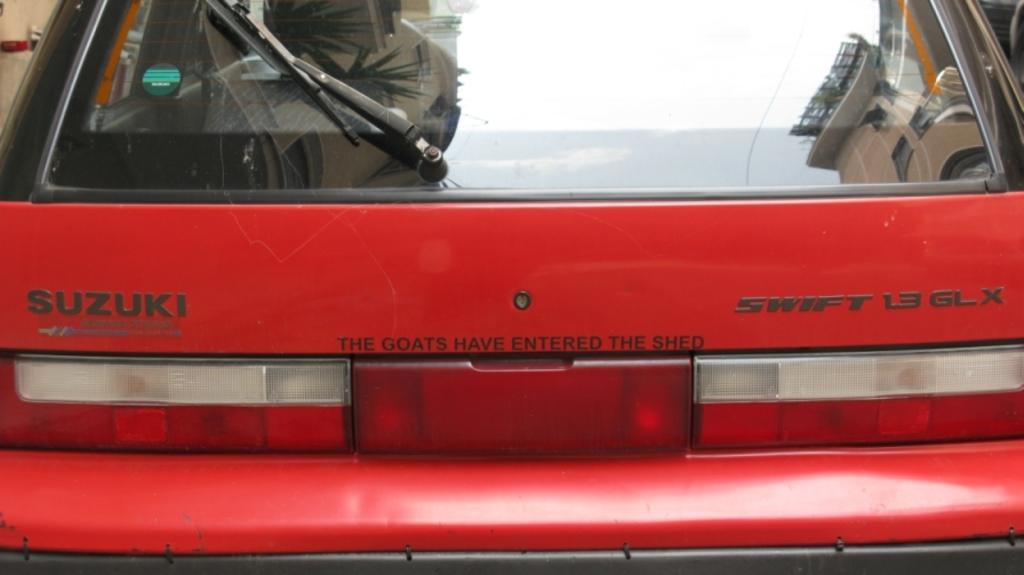What is the main subject of the image? There is a car in the image. What color is the car? The car is red. Can you identify the brand of the car? Yes, the name "Suzuki" is written on the car. What type of mint is growing near the car in the image? There is no mint present in the image; it only features a red car with the name "Suzuki" written on it. 